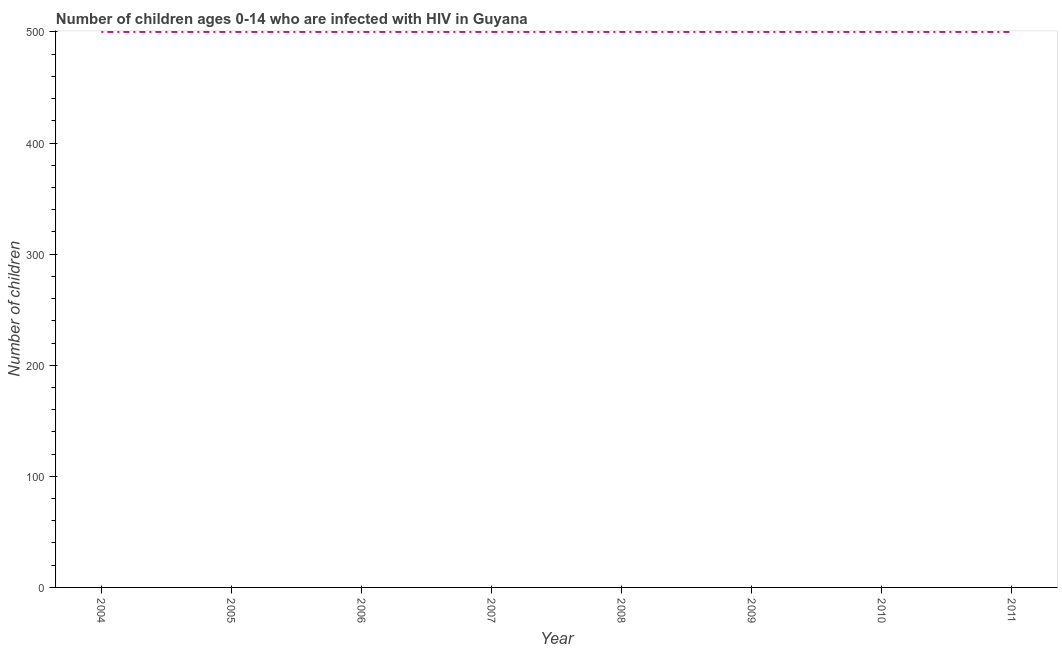What is the number of children living with hiv in 2008?
Your response must be concise. 500. Across all years, what is the maximum number of children living with hiv?
Provide a succinct answer. 500. Across all years, what is the minimum number of children living with hiv?
Ensure brevity in your answer.  500. In which year was the number of children living with hiv maximum?
Offer a very short reply. 2004. What is the sum of the number of children living with hiv?
Keep it short and to the point. 4000. What is the difference between the number of children living with hiv in 2007 and 2011?
Keep it short and to the point. 0. What is the median number of children living with hiv?
Ensure brevity in your answer.  500. Do a majority of the years between 2004 and 2008 (inclusive) have number of children living with hiv greater than 40 ?
Provide a succinct answer. Yes. What is the ratio of the number of children living with hiv in 2004 to that in 2008?
Make the answer very short. 1. Is the number of children living with hiv in 2008 less than that in 2011?
Provide a short and direct response. No. What is the difference between the highest and the second highest number of children living with hiv?
Your answer should be very brief. 0. In how many years, is the number of children living with hiv greater than the average number of children living with hiv taken over all years?
Provide a short and direct response. 0. How many lines are there?
Your answer should be very brief. 1. What is the title of the graph?
Your response must be concise. Number of children ages 0-14 who are infected with HIV in Guyana. What is the label or title of the X-axis?
Give a very brief answer. Year. What is the label or title of the Y-axis?
Your answer should be compact. Number of children. What is the Number of children of 2005?
Give a very brief answer. 500. What is the Number of children in 2006?
Make the answer very short. 500. What is the Number of children in 2007?
Your answer should be very brief. 500. What is the Number of children in 2008?
Provide a succinct answer. 500. What is the Number of children of 2010?
Keep it short and to the point. 500. What is the Number of children in 2011?
Offer a very short reply. 500. What is the difference between the Number of children in 2004 and 2006?
Provide a succinct answer. 0. What is the difference between the Number of children in 2004 and 2008?
Keep it short and to the point. 0. What is the difference between the Number of children in 2004 and 2010?
Provide a short and direct response. 0. What is the difference between the Number of children in 2005 and 2006?
Make the answer very short. 0. What is the difference between the Number of children in 2005 and 2007?
Offer a terse response. 0. What is the difference between the Number of children in 2005 and 2011?
Make the answer very short. 0. What is the difference between the Number of children in 2006 and 2010?
Your response must be concise. 0. What is the difference between the Number of children in 2006 and 2011?
Make the answer very short. 0. What is the difference between the Number of children in 2007 and 2008?
Offer a terse response. 0. What is the difference between the Number of children in 2007 and 2010?
Make the answer very short. 0. What is the difference between the Number of children in 2007 and 2011?
Offer a terse response. 0. What is the difference between the Number of children in 2008 and 2009?
Offer a very short reply. 0. What is the difference between the Number of children in 2008 and 2010?
Make the answer very short. 0. What is the difference between the Number of children in 2009 and 2010?
Keep it short and to the point. 0. What is the difference between the Number of children in 2009 and 2011?
Offer a terse response. 0. What is the difference between the Number of children in 2010 and 2011?
Ensure brevity in your answer.  0. What is the ratio of the Number of children in 2004 to that in 2005?
Your answer should be compact. 1. What is the ratio of the Number of children in 2004 to that in 2006?
Keep it short and to the point. 1. What is the ratio of the Number of children in 2004 to that in 2008?
Ensure brevity in your answer.  1. What is the ratio of the Number of children in 2004 to that in 2010?
Provide a short and direct response. 1. What is the ratio of the Number of children in 2005 to that in 2007?
Ensure brevity in your answer.  1. What is the ratio of the Number of children in 2005 to that in 2009?
Your answer should be compact. 1. What is the ratio of the Number of children in 2005 to that in 2010?
Provide a short and direct response. 1. What is the ratio of the Number of children in 2005 to that in 2011?
Offer a terse response. 1. What is the ratio of the Number of children in 2006 to that in 2007?
Provide a succinct answer. 1. What is the ratio of the Number of children in 2006 to that in 2008?
Your response must be concise. 1. What is the ratio of the Number of children in 2006 to that in 2009?
Offer a very short reply. 1. What is the ratio of the Number of children in 2006 to that in 2011?
Your answer should be very brief. 1. What is the ratio of the Number of children in 2007 to that in 2008?
Provide a succinct answer. 1. What is the ratio of the Number of children in 2007 to that in 2009?
Give a very brief answer. 1. What is the ratio of the Number of children in 2007 to that in 2010?
Make the answer very short. 1. What is the ratio of the Number of children in 2007 to that in 2011?
Make the answer very short. 1. What is the ratio of the Number of children in 2009 to that in 2010?
Give a very brief answer. 1. What is the ratio of the Number of children in 2010 to that in 2011?
Provide a succinct answer. 1. 